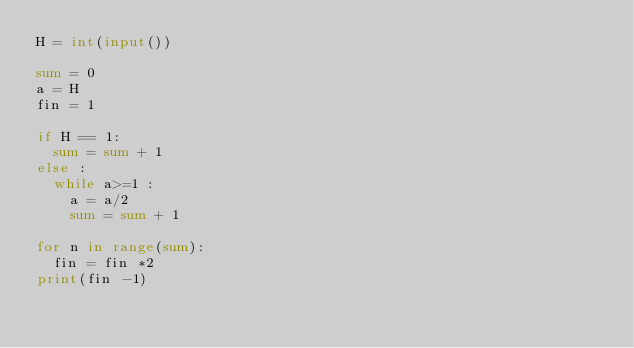Convert code to text. <code><loc_0><loc_0><loc_500><loc_500><_Python_>H = int(input())

sum = 0
a = H
fin = 1

if H == 1:
  sum = sum + 1
else :
  while a>=1 :
    a = a/2
    sum = sum + 1
    
for n in range(sum):
  fin = fin *2
print(fin -1)</code> 